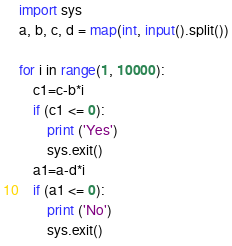<code> <loc_0><loc_0><loc_500><loc_500><_Python_>import sys
a, b, c, d = map(int, input().split())

for i in range(1, 10000):
    c1=c-b*i
    if (c1 <= 0):
        print ('Yes')
        sys.exit()
    a1=a-d*i
    if (a1 <= 0):
        print ('No')
        sys.exit()</code> 